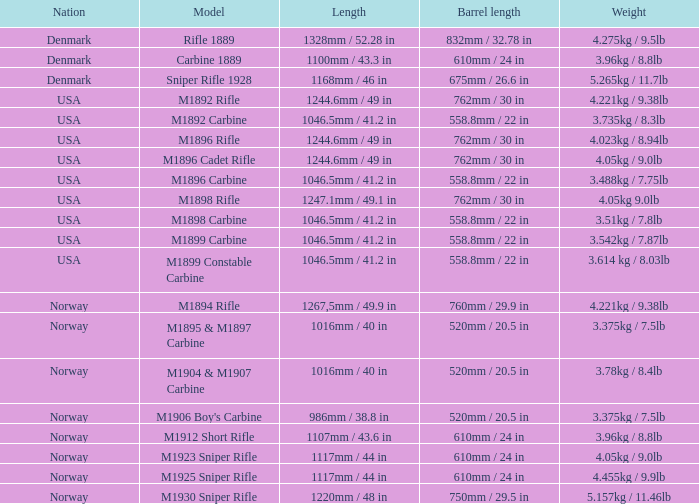5 inches? 1220mm / 48 in. 